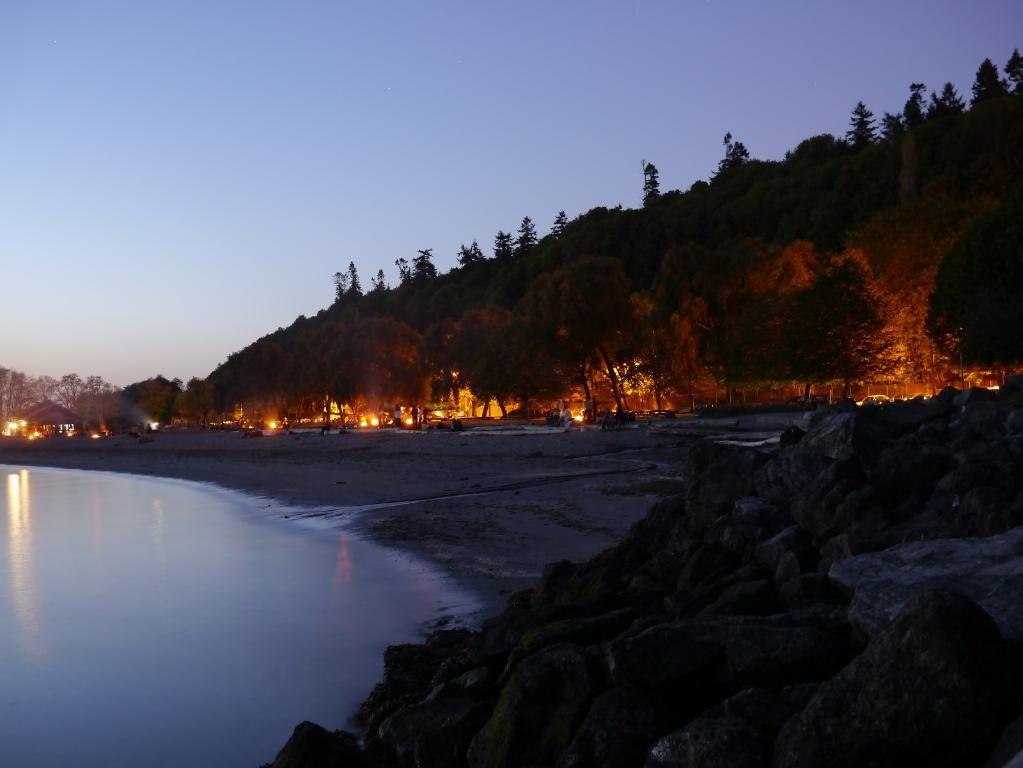Can you describe this image briefly? Here we can see water, trees and lights. Sky is in blue color. 